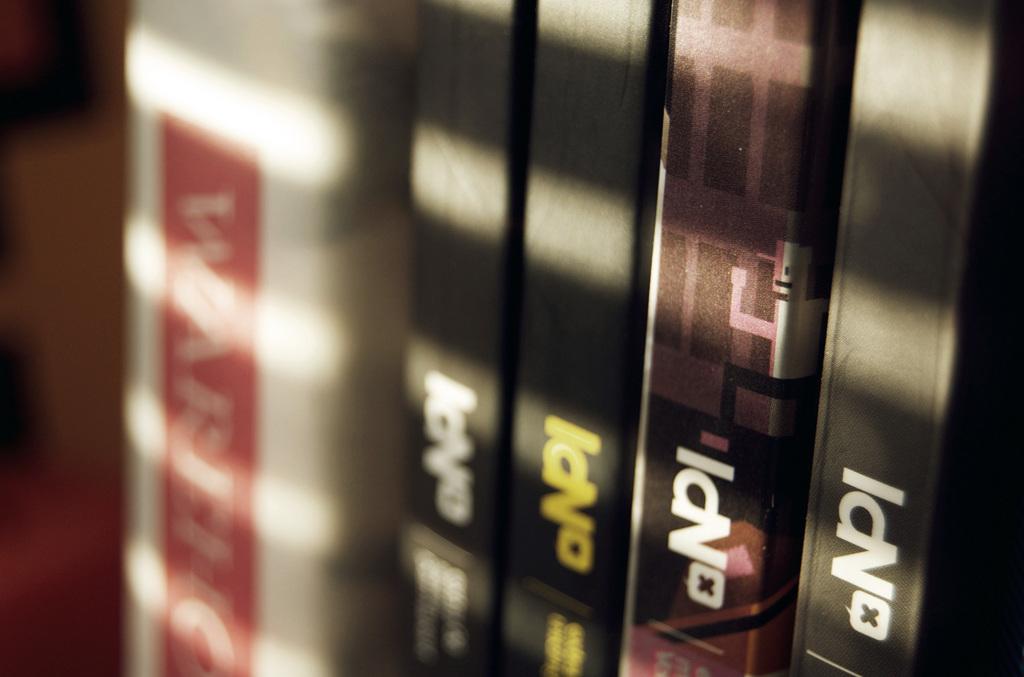What is the name on the four books?
Ensure brevity in your answer.  Npi. How many books are in the picture?
Make the answer very short. Answering does not require reading text in the image. 